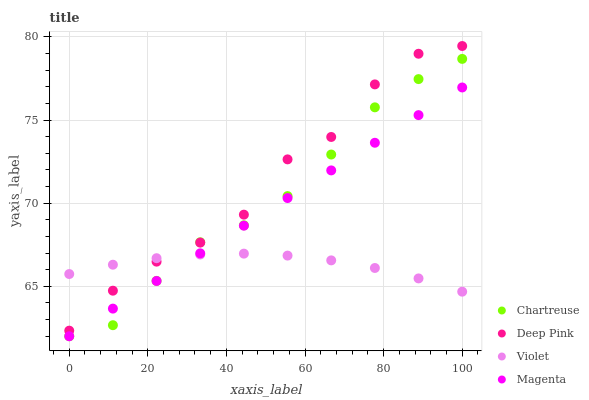Does Violet have the minimum area under the curve?
Answer yes or no. Yes. Does Deep Pink have the maximum area under the curve?
Answer yes or no. Yes. Does Magenta have the minimum area under the curve?
Answer yes or no. No. Does Magenta have the maximum area under the curve?
Answer yes or no. No. Is Magenta the smoothest?
Answer yes or no. Yes. Is Deep Pink the roughest?
Answer yes or no. Yes. Is Deep Pink the smoothest?
Answer yes or no. No. Is Magenta the roughest?
Answer yes or no. No. Does Chartreuse have the lowest value?
Answer yes or no. Yes. Does Deep Pink have the lowest value?
Answer yes or no. No. Does Deep Pink have the highest value?
Answer yes or no. Yes. Does Magenta have the highest value?
Answer yes or no. No. Is Magenta less than Deep Pink?
Answer yes or no. Yes. Is Deep Pink greater than Magenta?
Answer yes or no. Yes. Does Magenta intersect Chartreuse?
Answer yes or no. Yes. Is Magenta less than Chartreuse?
Answer yes or no. No. Is Magenta greater than Chartreuse?
Answer yes or no. No. Does Magenta intersect Deep Pink?
Answer yes or no. No. 